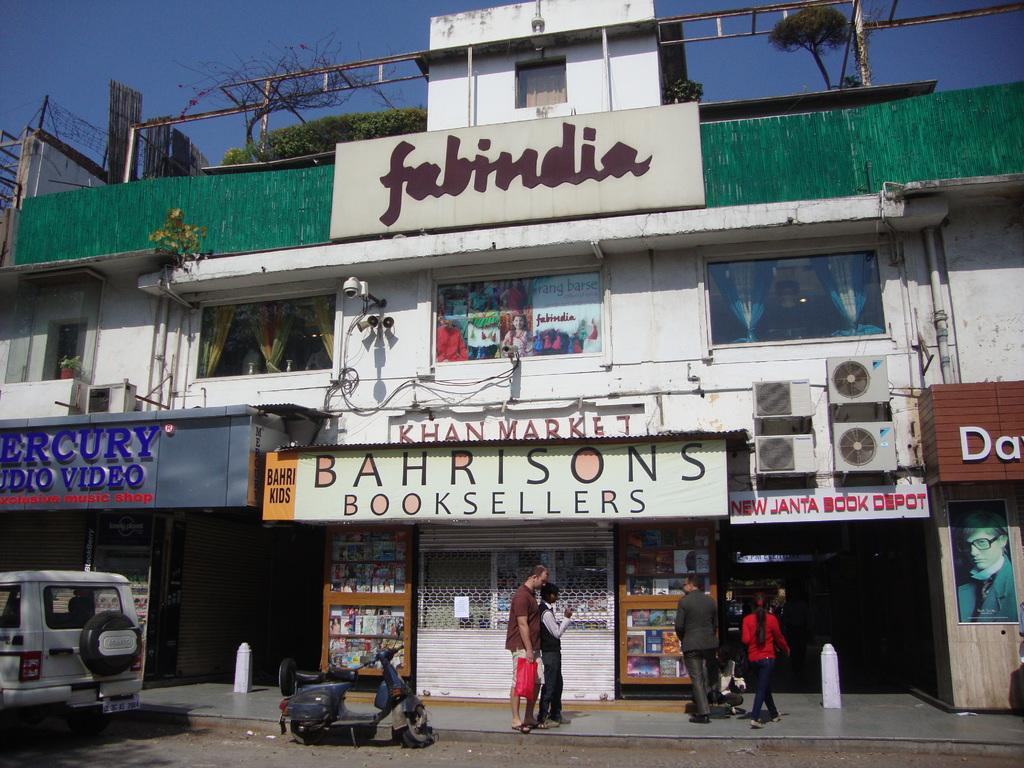What type of structure is visible in the image? There is a building in the image. What can be found inside the building? There are shops and book shelves visible in the image. What is happening on the road in the image? Vehicles are parked on the road in the image. What is happening with the people in the image? There are people walking in the image. What type of cherry is used as a texture for the paste in the image? There is no cherry, texture, or paste present in the image. 